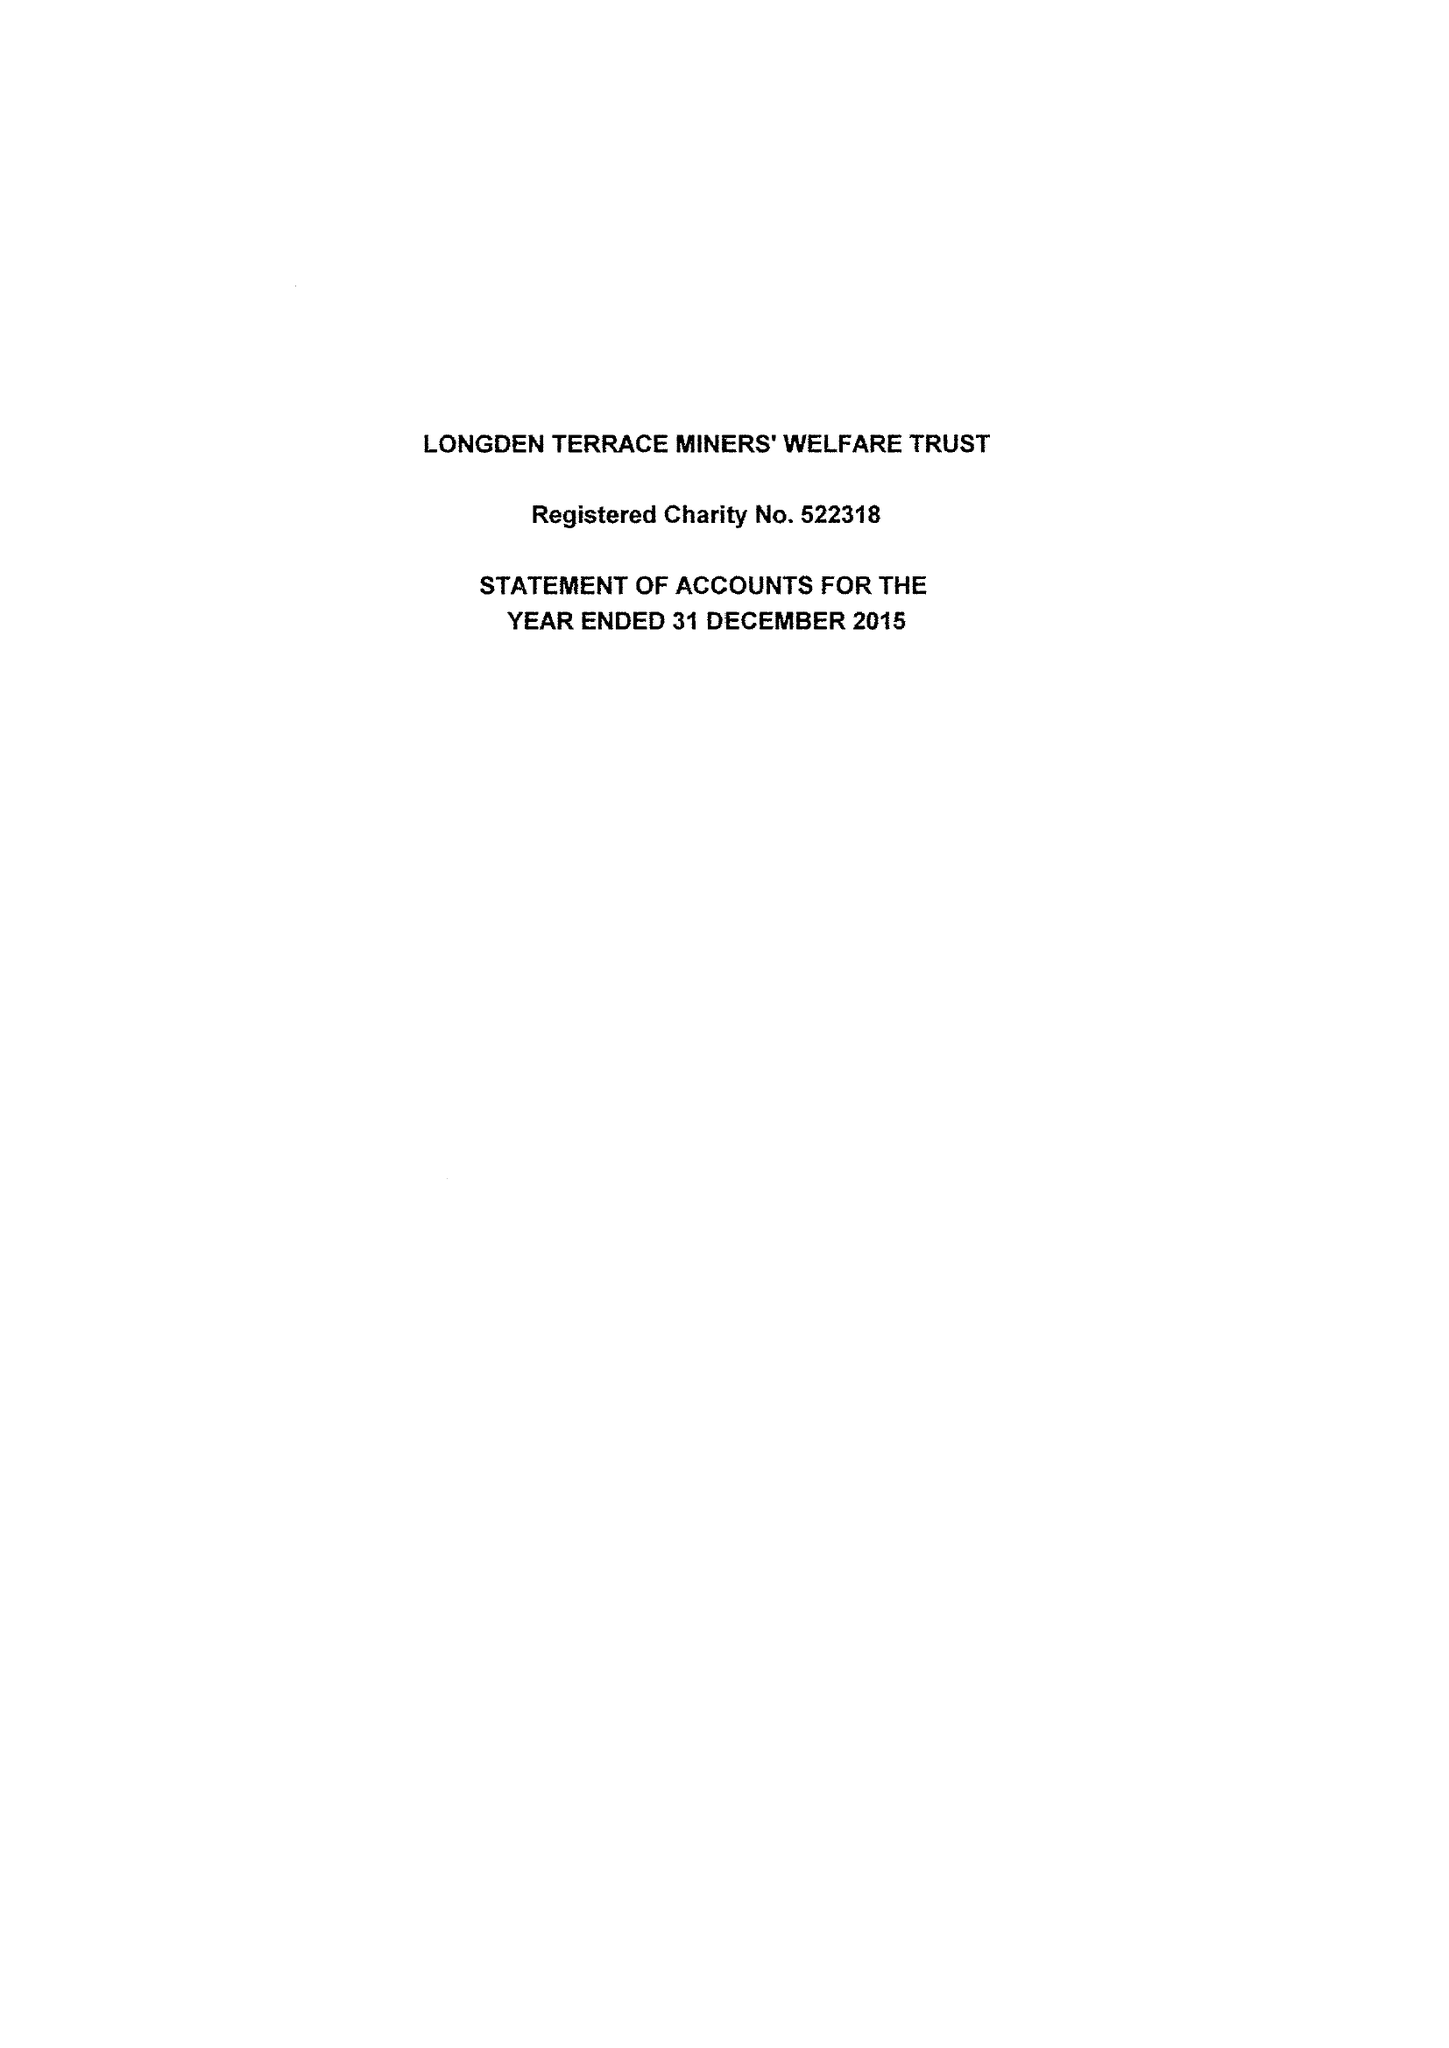What is the value for the spending_annually_in_british_pounds?
Answer the question using a single word or phrase. 47664.00 